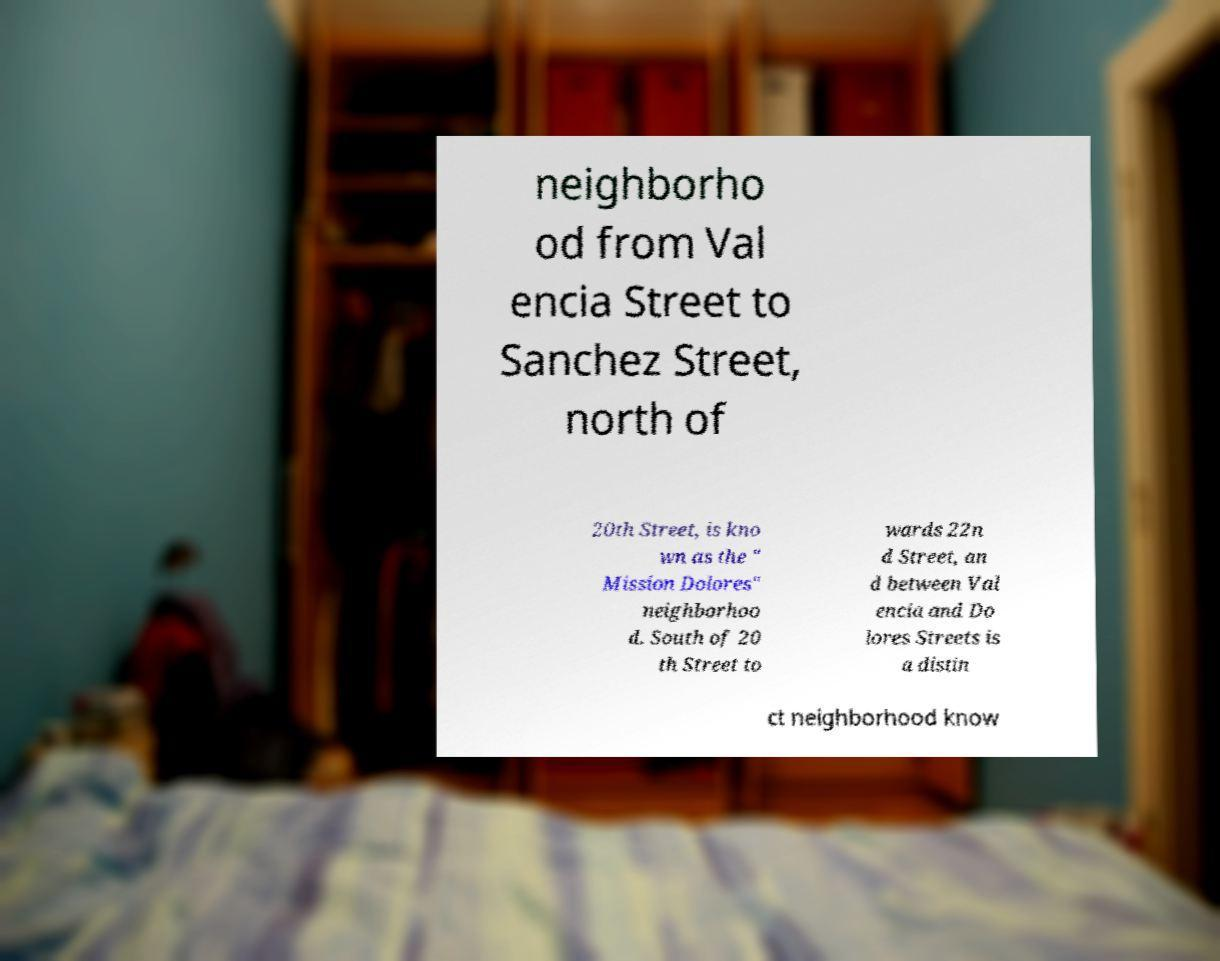Could you assist in decoding the text presented in this image and type it out clearly? neighborho od from Val encia Street to Sanchez Street, north of 20th Street, is kno wn as the " Mission Dolores" neighborhoo d. South of 20 th Street to wards 22n d Street, an d between Val encia and Do lores Streets is a distin ct neighborhood know 